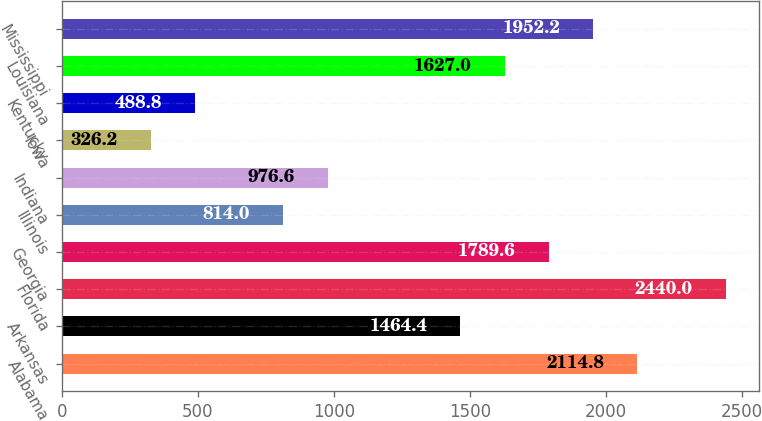<chart> <loc_0><loc_0><loc_500><loc_500><bar_chart><fcel>Alabama<fcel>Arkansas<fcel>Florida<fcel>Georgia<fcel>Illinois<fcel>Indiana<fcel>Iowa<fcel>Kentucky<fcel>Louisiana<fcel>Mississippi<nl><fcel>2114.8<fcel>1464.4<fcel>2440<fcel>1789.6<fcel>814<fcel>976.6<fcel>326.2<fcel>488.8<fcel>1627<fcel>1952.2<nl></chart> 